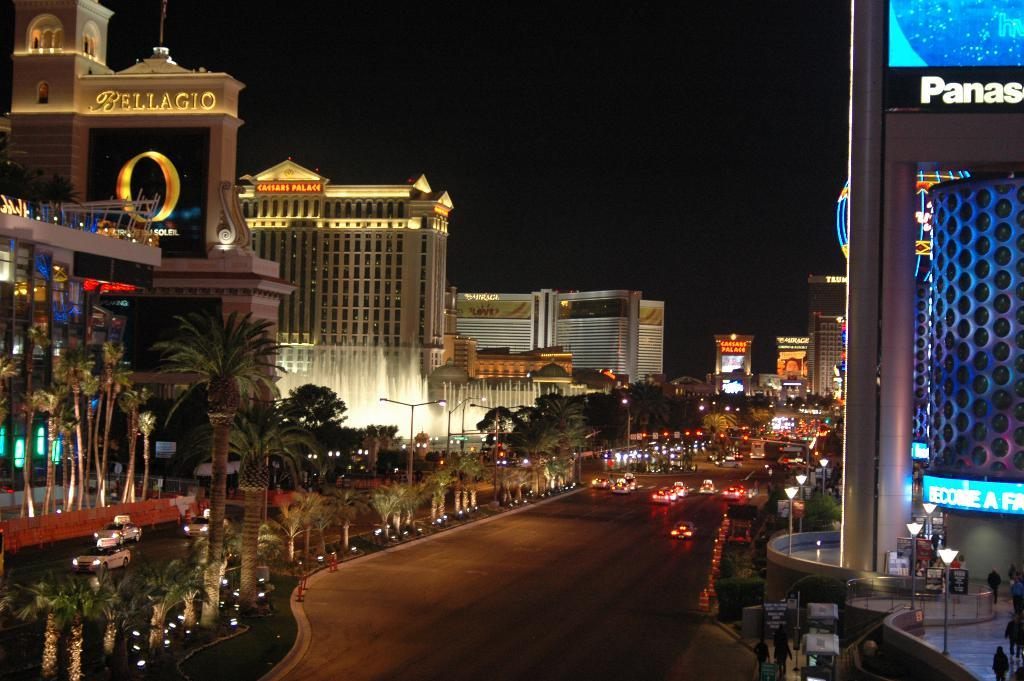<image>
Provide a brief description of the given image. A sign with Bellagio on it in gold letters. 